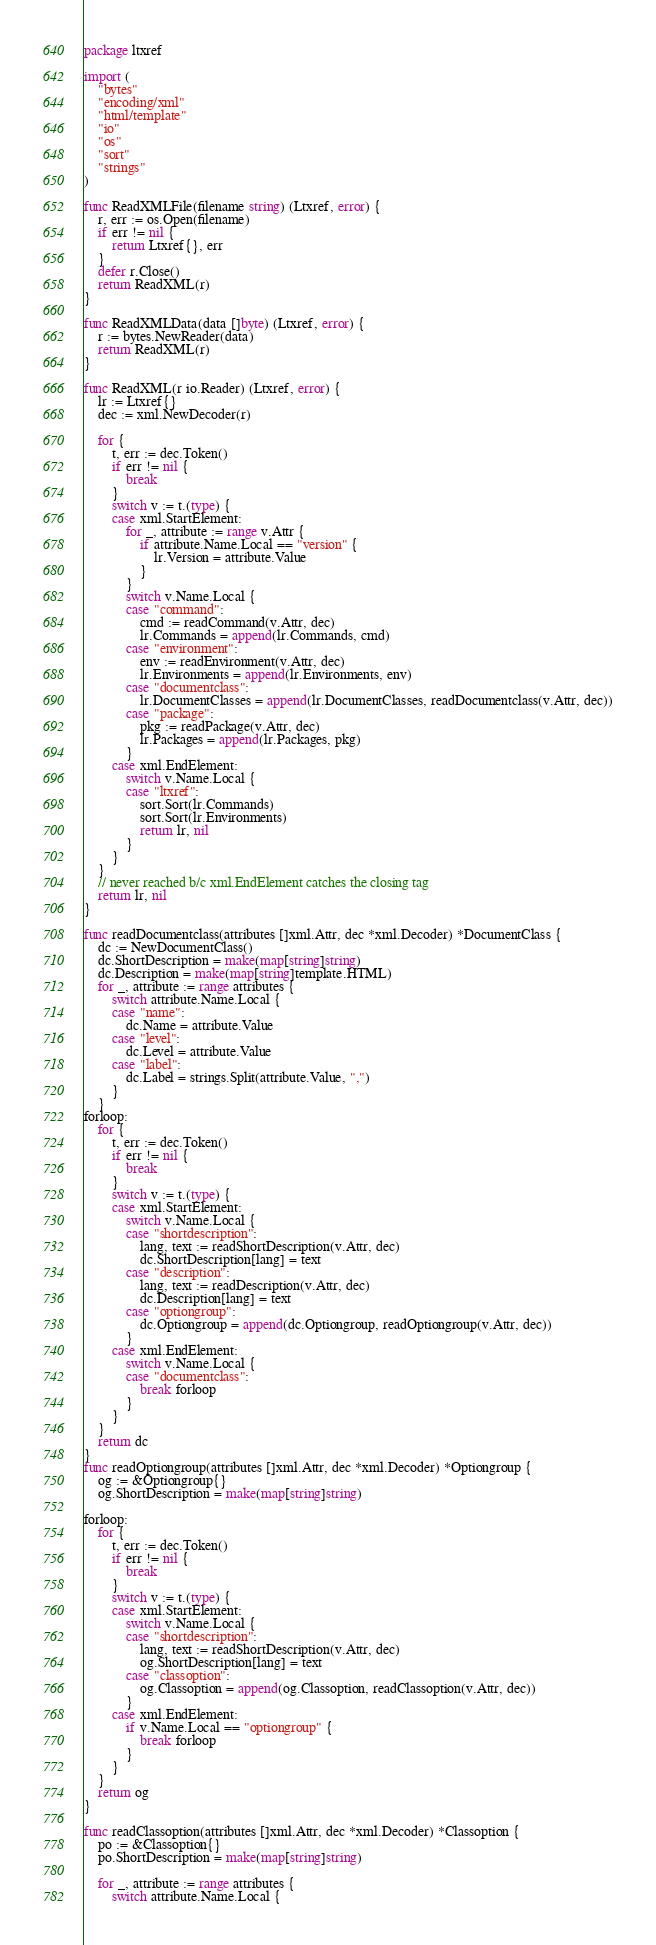<code> <loc_0><loc_0><loc_500><loc_500><_Go_>package ltxref

import (
	"bytes"
	"encoding/xml"
	"html/template"
	"io"
	"os"
	"sort"
	"strings"
)

func ReadXMLFile(filename string) (Ltxref, error) {
	r, err := os.Open(filename)
	if err != nil {
		return Ltxref{}, err
	}
	defer r.Close()
	return ReadXML(r)
}

func ReadXMLData(data []byte) (Ltxref, error) {
	r := bytes.NewReader(data)
	return ReadXML(r)
}

func ReadXML(r io.Reader) (Ltxref, error) {
	lr := Ltxref{}
	dec := xml.NewDecoder(r)

	for {
		t, err := dec.Token()
		if err != nil {
			break
		}
		switch v := t.(type) {
		case xml.StartElement:
			for _, attribute := range v.Attr {
				if attribute.Name.Local == "version" {
					lr.Version = attribute.Value
				}
			}
			switch v.Name.Local {
			case "command":
				cmd := readCommand(v.Attr, dec)
				lr.Commands = append(lr.Commands, cmd)
			case "environment":
				env := readEnvironment(v.Attr, dec)
				lr.Environments = append(lr.Environments, env)
			case "documentclass":
				lr.DocumentClasses = append(lr.DocumentClasses, readDocumentclass(v.Attr, dec))
			case "package":
				pkg := readPackage(v.Attr, dec)
				lr.Packages = append(lr.Packages, pkg)
			}
		case xml.EndElement:
			switch v.Name.Local {
			case "ltxref":
				sort.Sort(lr.Commands)
				sort.Sort(lr.Environments)
				return lr, nil
			}
		}
	}
	// never reached b/c xml.EndElement catches the closing tag
	return lr, nil
}

func readDocumentclass(attributes []xml.Attr, dec *xml.Decoder) *DocumentClass {
	dc := NewDocumentClass()
	dc.ShortDescription = make(map[string]string)
	dc.Description = make(map[string]template.HTML)
	for _, attribute := range attributes {
		switch attribute.Name.Local {
		case "name":
			dc.Name = attribute.Value
		case "level":
			dc.Level = attribute.Value
		case "label":
			dc.Label = strings.Split(attribute.Value, ",")
		}
	}
forloop:
	for {
		t, err := dec.Token()
		if err != nil {
			break
		}
		switch v := t.(type) {
		case xml.StartElement:
			switch v.Name.Local {
			case "shortdescription":
				lang, text := readShortDescription(v.Attr, dec)
				dc.ShortDescription[lang] = text
			case "description":
				lang, text := readDescription(v.Attr, dec)
				dc.Description[lang] = text
			case "optiongroup":
				dc.Optiongroup = append(dc.Optiongroup, readOptiongroup(v.Attr, dec))
			}
		case xml.EndElement:
			switch v.Name.Local {
			case "documentclass":
				break forloop
			}
		}
	}
	return dc
}
func readOptiongroup(attributes []xml.Attr, dec *xml.Decoder) *Optiongroup {
	og := &Optiongroup{}
	og.ShortDescription = make(map[string]string)

forloop:
	for {
		t, err := dec.Token()
		if err != nil {
			break
		}
		switch v := t.(type) {
		case xml.StartElement:
			switch v.Name.Local {
			case "shortdescription":
				lang, text := readShortDescription(v.Attr, dec)
				og.ShortDescription[lang] = text
			case "classoption":
				og.Classoption = append(og.Classoption, readClassoption(v.Attr, dec))
			}
		case xml.EndElement:
			if v.Name.Local == "optiongroup" {
				break forloop
			}
		}
	}
	return og
}

func readClassoption(attributes []xml.Attr, dec *xml.Decoder) *Classoption {
	po := &Classoption{}
	po.ShortDescription = make(map[string]string)

	for _, attribute := range attributes {
		switch attribute.Name.Local {</code> 